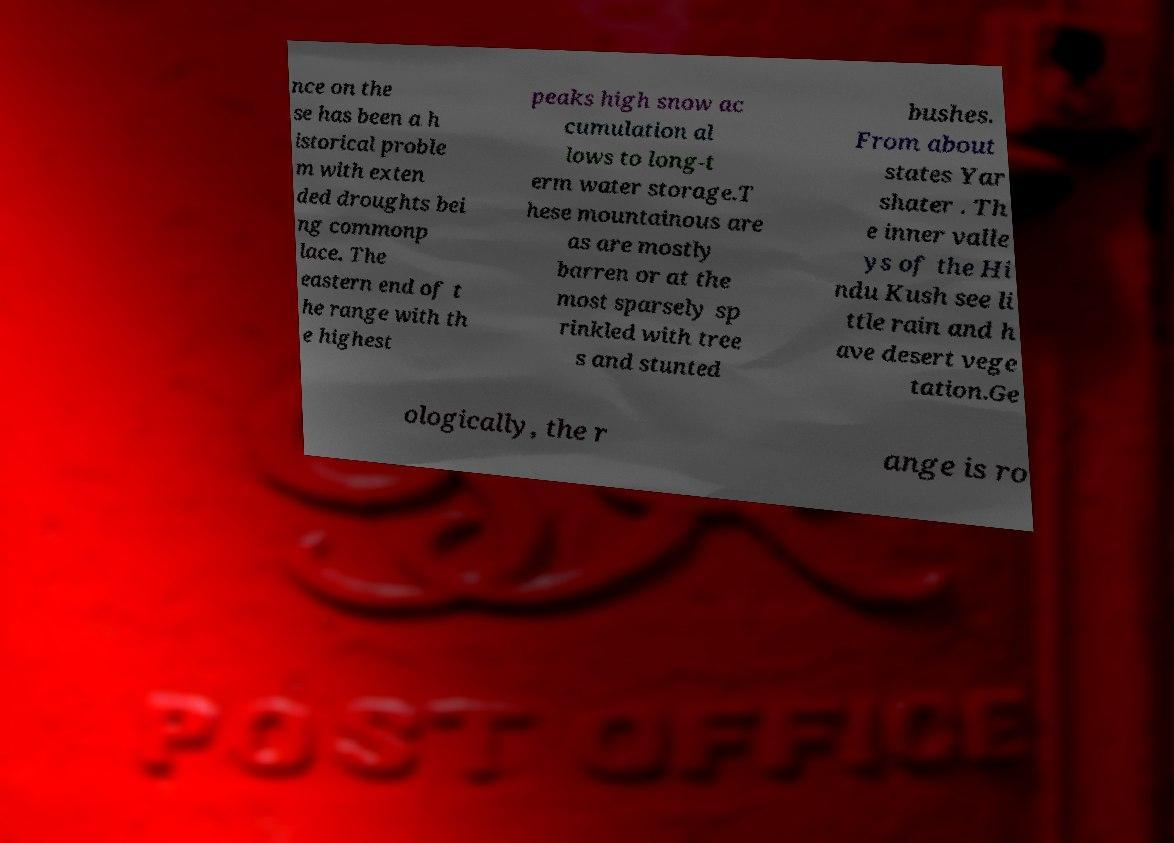Could you assist in decoding the text presented in this image and type it out clearly? nce on the se has been a h istorical proble m with exten ded droughts bei ng commonp lace. The eastern end of t he range with th e highest peaks high snow ac cumulation al lows to long-t erm water storage.T hese mountainous are as are mostly barren or at the most sparsely sp rinkled with tree s and stunted bushes. From about states Yar shater . Th e inner valle ys of the Hi ndu Kush see li ttle rain and h ave desert vege tation.Ge ologically, the r ange is ro 